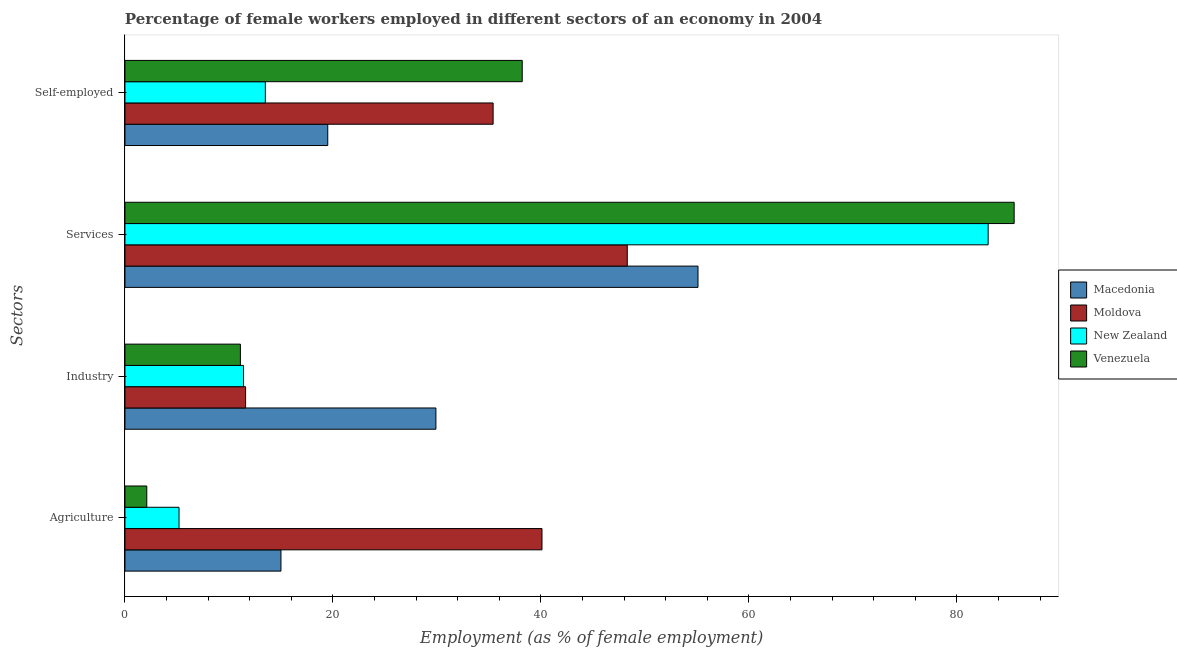How many different coloured bars are there?
Your response must be concise. 4. How many bars are there on the 2nd tick from the top?
Give a very brief answer. 4. What is the label of the 2nd group of bars from the top?
Your answer should be very brief. Services. What is the percentage of female workers in industry in Macedonia?
Offer a very short reply. 29.9. Across all countries, what is the maximum percentage of female workers in industry?
Offer a very short reply. 29.9. In which country was the percentage of female workers in services maximum?
Keep it short and to the point. Venezuela. In which country was the percentage of self employed female workers minimum?
Offer a very short reply. New Zealand. What is the total percentage of female workers in agriculture in the graph?
Give a very brief answer. 62.4. What is the difference between the percentage of self employed female workers in New Zealand and that in Venezuela?
Provide a succinct answer. -24.7. What is the difference between the percentage of female workers in industry in New Zealand and the percentage of self employed female workers in Venezuela?
Offer a terse response. -26.8. What is the average percentage of female workers in services per country?
Your answer should be compact. 67.97. What is the difference between the percentage of self employed female workers and percentage of female workers in agriculture in Macedonia?
Your answer should be very brief. 4.5. In how many countries, is the percentage of female workers in services greater than 56 %?
Your answer should be very brief. 2. What is the ratio of the percentage of female workers in agriculture in Venezuela to that in New Zealand?
Your answer should be compact. 0.4. Is the percentage of self employed female workers in New Zealand less than that in Venezuela?
Offer a very short reply. Yes. Is the difference between the percentage of female workers in industry in New Zealand and Macedonia greater than the difference between the percentage of self employed female workers in New Zealand and Macedonia?
Offer a very short reply. No. What is the difference between the highest and the second highest percentage of female workers in agriculture?
Ensure brevity in your answer.  25.1. What is the difference between the highest and the lowest percentage of female workers in agriculture?
Provide a succinct answer. 38. Is the sum of the percentage of female workers in industry in Venezuela and Macedonia greater than the maximum percentage of female workers in agriculture across all countries?
Ensure brevity in your answer.  Yes. What does the 1st bar from the top in Self-employed represents?
Your response must be concise. Venezuela. What does the 4th bar from the bottom in Services represents?
Give a very brief answer. Venezuela. How many bars are there?
Ensure brevity in your answer.  16. Are all the bars in the graph horizontal?
Offer a very short reply. Yes. How many countries are there in the graph?
Give a very brief answer. 4. What is the difference between two consecutive major ticks on the X-axis?
Ensure brevity in your answer.  20. Are the values on the major ticks of X-axis written in scientific E-notation?
Offer a very short reply. No. Does the graph contain any zero values?
Offer a very short reply. No. Does the graph contain grids?
Provide a short and direct response. No. What is the title of the graph?
Your answer should be very brief. Percentage of female workers employed in different sectors of an economy in 2004. What is the label or title of the X-axis?
Make the answer very short. Employment (as % of female employment). What is the label or title of the Y-axis?
Give a very brief answer. Sectors. What is the Employment (as % of female employment) of Moldova in Agriculture?
Offer a terse response. 40.1. What is the Employment (as % of female employment) of New Zealand in Agriculture?
Your response must be concise. 5.2. What is the Employment (as % of female employment) in Venezuela in Agriculture?
Provide a succinct answer. 2.1. What is the Employment (as % of female employment) of Macedonia in Industry?
Give a very brief answer. 29.9. What is the Employment (as % of female employment) in Moldova in Industry?
Ensure brevity in your answer.  11.6. What is the Employment (as % of female employment) of New Zealand in Industry?
Make the answer very short. 11.4. What is the Employment (as % of female employment) in Venezuela in Industry?
Offer a terse response. 11.1. What is the Employment (as % of female employment) of Macedonia in Services?
Provide a short and direct response. 55.1. What is the Employment (as % of female employment) of Moldova in Services?
Your answer should be compact. 48.3. What is the Employment (as % of female employment) of Venezuela in Services?
Offer a very short reply. 85.5. What is the Employment (as % of female employment) of Macedonia in Self-employed?
Your answer should be compact. 19.5. What is the Employment (as % of female employment) of Moldova in Self-employed?
Your answer should be compact. 35.4. What is the Employment (as % of female employment) of New Zealand in Self-employed?
Ensure brevity in your answer.  13.5. What is the Employment (as % of female employment) of Venezuela in Self-employed?
Offer a very short reply. 38.2. Across all Sectors, what is the maximum Employment (as % of female employment) of Macedonia?
Give a very brief answer. 55.1. Across all Sectors, what is the maximum Employment (as % of female employment) of Moldova?
Offer a terse response. 48.3. Across all Sectors, what is the maximum Employment (as % of female employment) of Venezuela?
Keep it short and to the point. 85.5. Across all Sectors, what is the minimum Employment (as % of female employment) of Macedonia?
Make the answer very short. 15. Across all Sectors, what is the minimum Employment (as % of female employment) in Moldova?
Your answer should be very brief. 11.6. Across all Sectors, what is the minimum Employment (as % of female employment) of New Zealand?
Keep it short and to the point. 5.2. Across all Sectors, what is the minimum Employment (as % of female employment) in Venezuela?
Provide a succinct answer. 2.1. What is the total Employment (as % of female employment) of Macedonia in the graph?
Offer a terse response. 119.5. What is the total Employment (as % of female employment) of Moldova in the graph?
Provide a short and direct response. 135.4. What is the total Employment (as % of female employment) in New Zealand in the graph?
Your answer should be compact. 113.1. What is the total Employment (as % of female employment) in Venezuela in the graph?
Provide a succinct answer. 136.9. What is the difference between the Employment (as % of female employment) in Macedonia in Agriculture and that in Industry?
Offer a very short reply. -14.9. What is the difference between the Employment (as % of female employment) of Moldova in Agriculture and that in Industry?
Offer a very short reply. 28.5. What is the difference between the Employment (as % of female employment) of New Zealand in Agriculture and that in Industry?
Provide a succinct answer. -6.2. What is the difference between the Employment (as % of female employment) in Macedonia in Agriculture and that in Services?
Offer a very short reply. -40.1. What is the difference between the Employment (as % of female employment) of Moldova in Agriculture and that in Services?
Offer a very short reply. -8.2. What is the difference between the Employment (as % of female employment) in New Zealand in Agriculture and that in Services?
Provide a succinct answer. -77.8. What is the difference between the Employment (as % of female employment) of Venezuela in Agriculture and that in Services?
Provide a succinct answer. -83.4. What is the difference between the Employment (as % of female employment) of Macedonia in Agriculture and that in Self-employed?
Provide a short and direct response. -4.5. What is the difference between the Employment (as % of female employment) in Moldova in Agriculture and that in Self-employed?
Give a very brief answer. 4.7. What is the difference between the Employment (as % of female employment) in New Zealand in Agriculture and that in Self-employed?
Provide a short and direct response. -8.3. What is the difference between the Employment (as % of female employment) of Venezuela in Agriculture and that in Self-employed?
Your answer should be very brief. -36.1. What is the difference between the Employment (as % of female employment) in Macedonia in Industry and that in Services?
Keep it short and to the point. -25.2. What is the difference between the Employment (as % of female employment) of Moldova in Industry and that in Services?
Make the answer very short. -36.7. What is the difference between the Employment (as % of female employment) of New Zealand in Industry and that in Services?
Your response must be concise. -71.6. What is the difference between the Employment (as % of female employment) in Venezuela in Industry and that in Services?
Provide a short and direct response. -74.4. What is the difference between the Employment (as % of female employment) in Moldova in Industry and that in Self-employed?
Make the answer very short. -23.8. What is the difference between the Employment (as % of female employment) in New Zealand in Industry and that in Self-employed?
Provide a succinct answer. -2.1. What is the difference between the Employment (as % of female employment) of Venezuela in Industry and that in Self-employed?
Provide a short and direct response. -27.1. What is the difference between the Employment (as % of female employment) in Macedonia in Services and that in Self-employed?
Provide a succinct answer. 35.6. What is the difference between the Employment (as % of female employment) in Moldova in Services and that in Self-employed?
Offer a very short reply. 12.9. What is the difference between the Employment (as % of female employment) in New Zealand in Services and that in Self-employed?
Your answer should be very brief. 69.5. What is the difference between the Employment (as % of female employment) of Venezuela in Services and that in Self-employed?
Give a very brief answer. 47.3. What is the difference between the Employment (as % of female employment) in Moldova in Agriculture and the Employment (as % of female employment) in New Zealand in Industry?
Your answer should be very brief. 28.7. What is the difference between the Employment (as % of female employment) of New Zealand in Agriculture and the Employment (as % of female employment) of Venezuela in Industry?
Make the answer very short. -5.9. What is the difference between the Employment (as % of female employment) of Macedonia in Agriculture and the Employment (as % of female employment) of Moldova in Services?
Your answer should be very brief. -33.3. What is the difference between the Employment (as % of female employment) in Macedonia in Agriculture and the Employment (as % of female employment) in New Zealand in Services?
Make the answer very short. -68. What is the difference between the Employment (as % of female employment) of Macedonia in Agriculture and the Employment (as % of female employment) of Venezuela in Services?
Keep it short and to the point. -70.5. What is the difference between the Employment (as % of female employment) of Moldova in Agriculture and the Employment (as % of female employment) of New Zealand in Services?
Give a very brief answer. -42.9. What is the difference between the Employment (as % of female employment) of Moldova in Agriculture and the Employment (as % of female employment) of Venezuela in Services?
Give a very brief answer. -45.4. What is the difference between the Employment (as % of female employment) of New Zealand in Agriculture and the Employment (as % of female employment) of Venezuela in Services?
Give a very brief answer. -80.3. What is the difference between the Employment (as % of female employment) of Macedonia in Agriculture and the Employment (as % of female employment) of Moldova in Self-employed?
Make the answer very short. -20.4. What is the difference between the Employment (as % of female employment) in Macedonia in Agriculture and the Employment (as % of female employment) in Venezuela in Self-employed?
Your response must be concise. -23.2. What is the difference between the Employment (as % of female employment) in Moldova in Agriculture and the Employment (as % of female employment) in New Zealand in Self-employed?
Give a very brief answer. 26.6. What is the difference between the Employment (as % of female employment) in Moldova in Agriculture and the Employment (as % of female employment) in Venezuela in Self-employed?
Offer a terse response. 1.9. What is the difference between the Employment (as % of female employment) in New Zealand in Agriculture and the Employment (as % of female employment) in Venezuela in Self-employed?
Your response must be concise. -33. What is the difference between the Employment (as % of female employment) of Macedonia in Industry and the Employment (as % of female employment) of Moldova in Services?
Offer a very short reply. -18.4. What is the difference between the Employment (as % of female employment) in Macedonia in Industry and the Employment (as % of female employment) in New Zealand in Services?
Give a very brief answer. -53.1. What is the difference between the Employment (as % of female employment) of Macedonia in Industry and the Employment (as % of female employment) of Venezuela in Services?
Your answer should be very brief. -55.6. What is the difference between the Employment (as % of female employment) in Moldova in Industry and the Employment (as % of female employment) in New Zealand in Services?
Give a very brief answer. -71.4. What is the difference between the Employment (as % of female employment) of Moldova in Industry and the Employment (as % of female employment) of Venezuela in Services?
Provide a short and direct response. -73.9. What is the difference between the Employment (as % of female employment) in New Zealand in Industry and the Employment (as % of female employment) in Venezuela in Services?
Your answer should be very brief. -74.1. What is the difference between the Employment (as % of female employment) in Macedonia in Industry and the Employment (as % of female employment) in Venezuela in Self-employed?
Your answer should be very brief. -8.3. What is the difference between the Employment (as % of female employment) in Moldova in Industry and the Employment (as % of female employment) in New Zealand in Self-employed?
Your answer should be compact. -1.9. What is the difference between the Employment (as % of female employment) in Moldova in Industry and the Employment (as % of female employment) in Venezuela in Self-employed?
Provide a short and direct response. -26.6. What is the difference between the Employment (as % of female employment) of New Zealand in Industry and the Employment (as % of female employment) of Venezuela in Self-employed?
Provide a short and direct response. -26.8. What is the difference between the Employment (as % of female employment) in Macedonia in Services and the Employment (as % of female employment) in Moldova in Self-employed?
Your response must be concise. 19.7. What is the difference between the Employment (as % of female employment) of Macedonia in Services and the Employment (as % of female employment) of New Zealand in Self-employed?
Your answer should be compact. 41.6. What is the difference between the Employment (as % of female employment) in Moldova in Services and the Employment (as % of female employment) in New Zealand in Self-employed?
Your response must be concise. 34.8. What is the difference between the Employment (as % of female employment) in New Zealand in Services and the Employment (as % of female employment) in Venezuela in Self-employed?
Offer a terse response. 44.8. What is the average Employment (as % of female employment) in Macedonia per Sectors?
Your response must be concise. 29.88. What is the average Employment (as % of female employment) of Moldova per Sectors?
Provide a succinct answer. 33.85. What is the average Employment (as % of female employment) of New Zealand per Sectors?
Provide a succinct answer. 28.27. What is the average Employment (as % of female employment) of Venezuela per Sectors?
Keep it short and to the point. 34.23. What is the difference between the Employment (as % of female employment) in Macedonia and Employment (as % of female employment) in Moldova in Agriculture?
Your answer should be compact. -25.1. What is the difference between the Employment (as % of female employment) in Moldova and Employment (as % of female employment) in New Zealand in Agriculture?
Your answer should be very brief. 34.9. What is the difference between the Employment (as % of female employment) of New Zealand and Employment (as % of female employment) of Venezuela in Agriculture?
Your answer should be compact. 3.1. What is the difference between the Employment (as % of female employment) in Macedonia and Employment (as % of female employment) in Moldova in Industry?
Provide a short and direct response. 18.3. What is the difference between the Employment (as % of female employment) in Macedonia and Employment (as % of female employment) in Venezuela in Industry?
Your response must be concise. 18.8. What is the difference between the Employment (as % of female employment) in Moldova and Employment (as % of female employment) in New Zealand in Industry?
Your response must be concise. 0.2. What is the difference between the Employment (as % of female employment) of Moldova and Employment (as % of female employment) of Venezuela in Industry?
Make the answer very short. 0.5. What is the difference between the Employment (as % of female employment) of New Zealand and Employment (as % of female employment) of Venezuela in Industry?
Your answer should be very brief. 0.3. What is the difference between the Employment (as % of female employment) in Macedonia and Employment (as % of female employment) in Moldova in Services?
Provide a succinct answer. 6.8. What is the difference between the Employment (as % of female employment) in Macedonia and Employment (as % of female employment) in New Zealand in Services?
Keep it short and to the point. -27.9. What is the difference between the Employment (as % of female employment) in Macedonia and Employment (as % of female employment) in Venezuela in Services?
Provide a succinct answer. -30.4. What is the difference between the Employment (as % of female employment) in Moldova and Employment (as % of female employment) in New Zealand in Services?
Provide a succinct answer. -34.7. What is the difference between the Employment (as % of female employment) in Moldova and Employment (as % of female employment) in Venezuela in Services?
Offer a terse response. -37.2. What is the difference between the Employment (as % of female employment) in New Zealand and Employment (as % of female employment) in Venezuela in Services?
Make the answer very short. -2.5. What is the difference between the Employment (as % of female employment) in Macedonia and Employment (as % of female employment) in Moldova in Self-employed?
Give a very brief answer. -15.9. What is the difference between the Employment (as % of female employment) in Macedonia and Employment (as % of female employment) in New Zealand in Self-employed?
Keep it short and to the point. 6. What is the difference between the Employment (as % of female employment) of Macedonia and Employment (as % of female employment) of Venezuela in Self-employed?
Keep it short and to the point. -18.7. What is the difference between the Employment (as % of female employment) in Moldova and Employment (as % of female employment) in New Zealand in Self-employed?
Provide a short and direct response. 21.9. What is the difference between the Employment (as % of female employment) of New Zealand and Employment (as % of female employment) of Venezuela in Self-employed?
Offer a terse response. -24.7. What is the ratio of the Employment (as % of female employment) of Macedonia in Agriculture to that in Industry?
Provide a succinct answer. 0.5. What is the ratio of the Employment (as % of female employment) in Moldova in Agriculture to that in Industry?
Your answer should be very brief. 3.46. What is the ratio of the Employment (as % of female employment) of New Zealand in Agriculture to that in Industry?
Your answer should be very brief. 0.46. What is the ratio of the Employment (as % of female employment) in Venezuela in Agriculture to that in Industry?
Your answer should be very brief. 0.19. What is the ratio of the Employment (as % of female employment) of Macedonia in Agriculture to that in Services?
Provide a succinct answer. 0.27. What is the ratio of the Employment (as % of female employment) of Moldova in Agriculture to that in Services?
Provide a short and direct response. 0.83. What is the ratio of the Employment (as % of female employment) of New Zealand in Agriculture to that in Services?
Your answer should be very brief. 0.06. What is the ratio of the Employment (as % of female employment) in Venezuela in Agriculture to that in Services?
Offer a terse response. 0.02. What is the ratio of the Employment (as % of female employment) of Macedonia in Agriculture to that in Self-employed?
Offer a very short reply. 0.77. What is the ratio of the Employment (as % of female employment) of Moldova in Agriculture to that in Self-employed?
Keep it short and to the point. 1.13. What is the ratio of the Employment (as % of female employment) of New Zealand in Agriculture to that in Self-employed?
Your response must be concise. 0.39. What is the ratio of the Employment (as % of female employment) of Venezuela in Agriculture to that in Self-employed?
Make the answer very short. 0.06. What is the ratio of the Employment (as % of female employment) in Macedonia in Industry to that in Services?
Offer a terse response. 0.54. What is the ratio of the Employment (as % of female employment) in Moldova in Industry to that in Services?
Provide a succinct answer. 0.24. What is the ratio of the Employment (as % of female employment) in New Zealand in Industry to that in Services?
Ensure brevity in your answer.  0.14. What is the ratio of the Employment (as % of female employment) of Venezuela in Industry to that in Services?
Your response must be concise. 0.13. What is the ratio of the Employment (as % of female employment) in Macedonia in Industry to that in Self-employed?
Your answer should be compact. 1.53. What is the ratio of the Employment (as % of female employment) in Moldova in Industry to that in Self-employed?
Offer a terse response. 0.33. What is the ratio of the Employment (as % of female employment) of New Zealand in Industry to that in Self-employed?
Give a very brief answer. 0.84. What is the ratio of the Employment (as % of female employment) of Venezuela in Industry to that in Self-employed?
Provide a short and direct response. 0.29. What is the ratio of the Employment (as % of female employment) of Macedonia in Services to that in Self-employed?
Your response must be concise. 2.83. What is the ratio of the Employment (as % of female employment) in Moldova in Services to that in Self-employed?
Your response must be concise. 1.36. What is the ratio of the Employment (as % of female employment) in New Zealand in Services to that in Self-employed?
Your answer should be compact. 6.15. What is the ratio of the Employment (as % of female employment) of Venezuela in Services to that in Self-employed?
Offer a very short reply. 2.24. What is the difference between the highest and the second highest Employment (as % of female employment) in Macedonia?
Your answer should be very brief. 25.2. What is the difference between the highest and the second highest Employment (as % of female employment) in New Zealand?
Provide a short and direct response. 69.5. What is the difference between the highest and the second highest Employment (as % of female employment) in Venezuela?
Keep it short and to the point. 47.3. What is the difference between the highest and the lowest Employment (as % of female employment) in Macedonia?
Offer a very short reply. 40.1. What is the difference between the highest and the lowest Employment (as % of female employment) of Moldova?
Provide a short and direct response. 36.7. What is the difference between the highest and the lowest Employment (as % of female employment) in New Zealand?
Give a very brief answer. 77.8. What is the difference between the highest and the lowest Employment (as % of female employment) in Venezuela?
Offer a terse response. 83.4. 